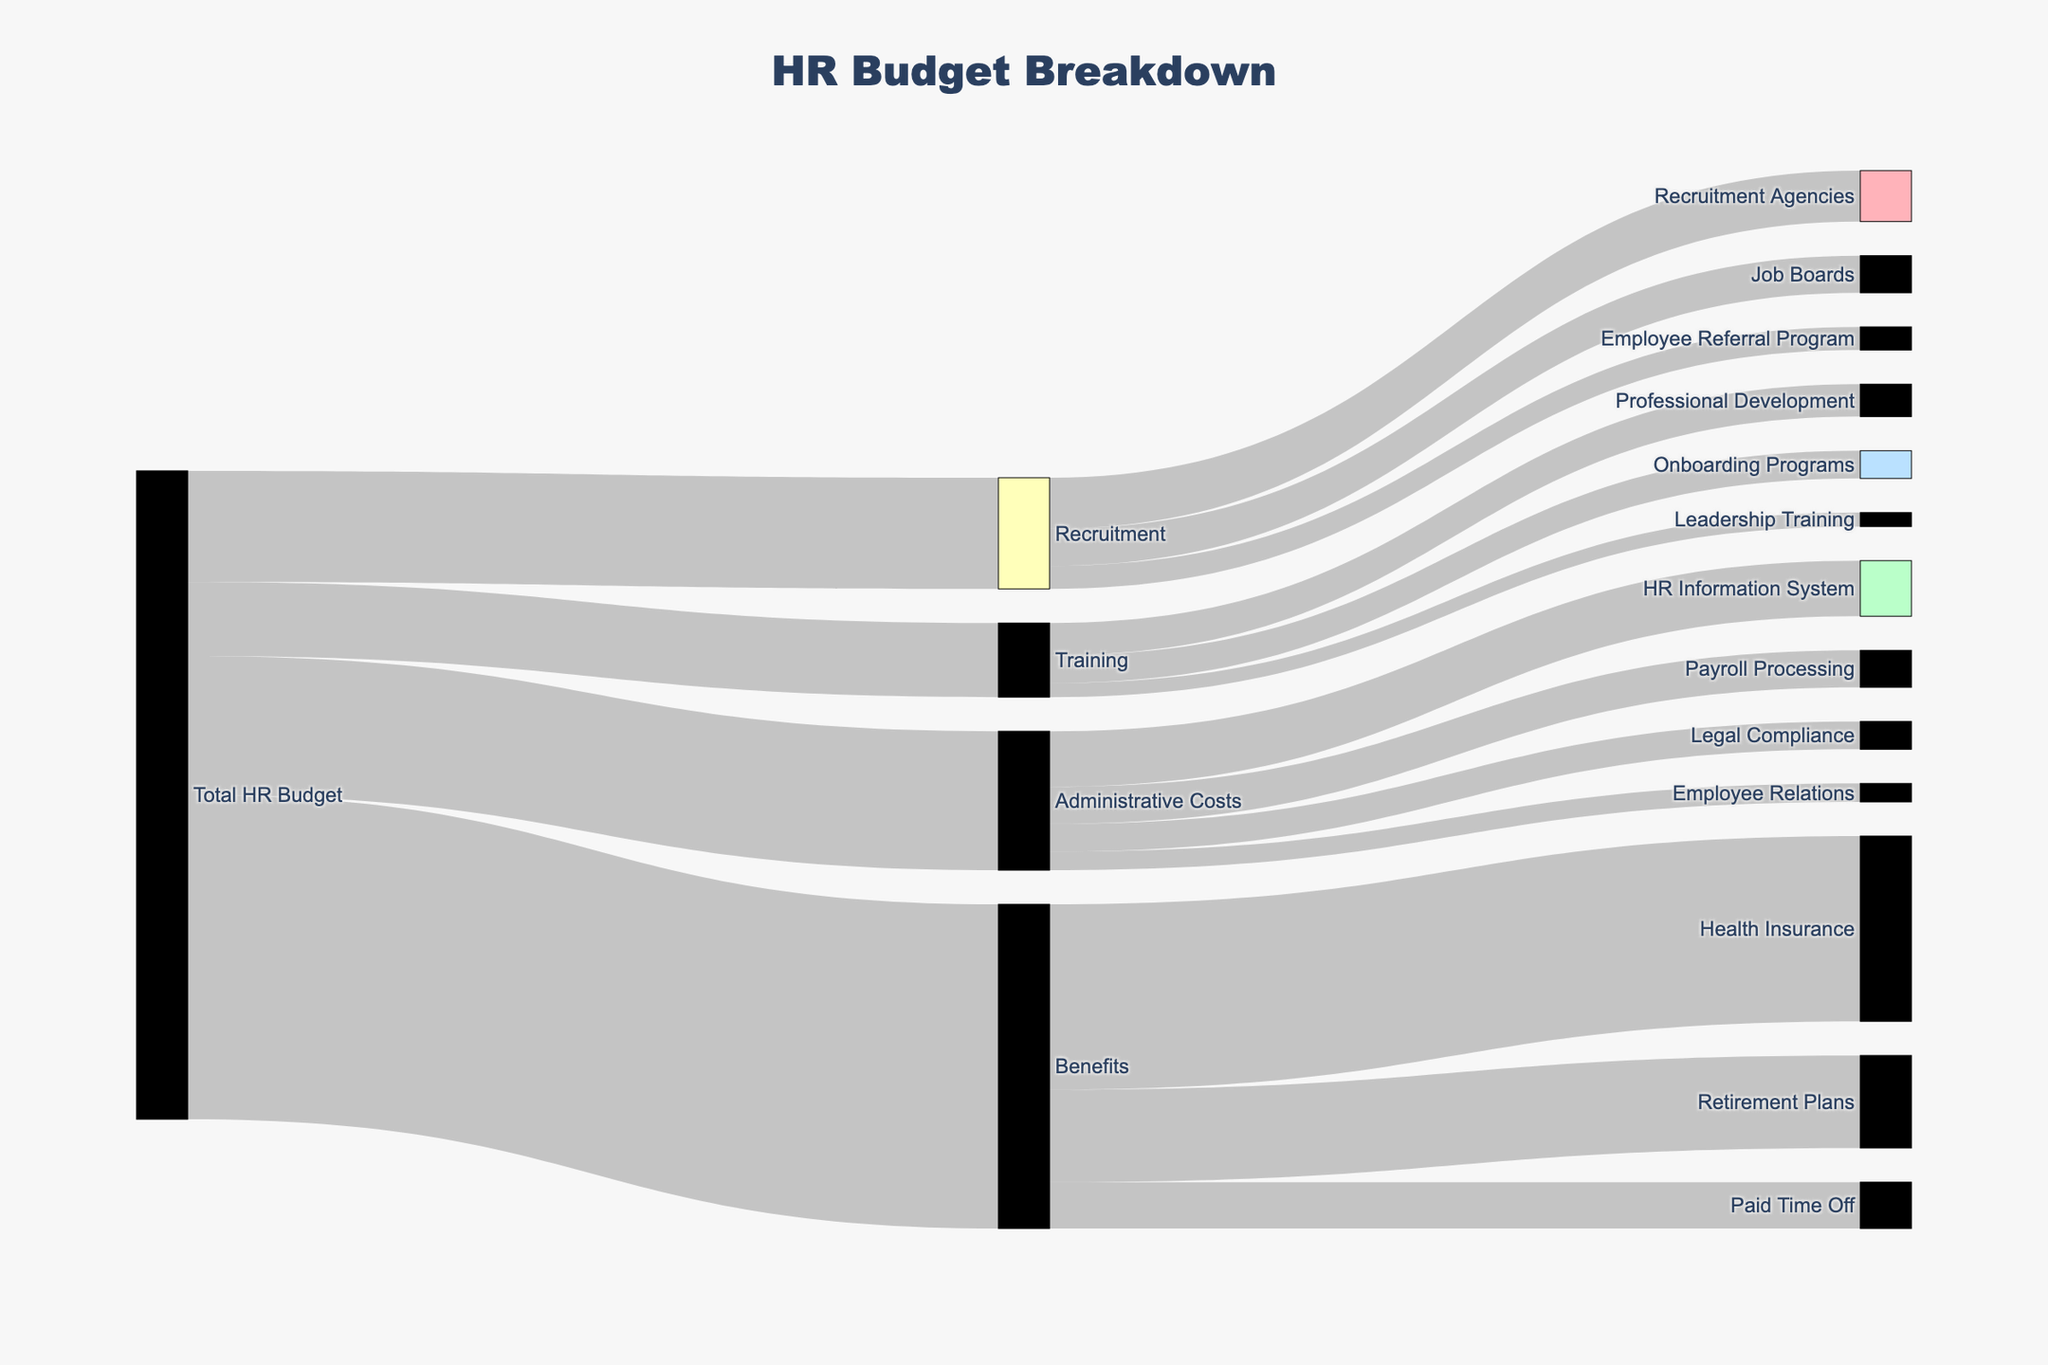How much of the total HR budget is allocated to Recruitment? The Sankey diagram shows the flow from the Total HR Budget to Recruitment. According to the figure, the amount directed to Recruitment is clearly labeled.
Answer: $120,000 How does the expenditure on Job Boards compare to Recruitment Agencies? To answer this, we need to find both values flowing from Recruitment. The diagram shows $40,000 for Job Boards and $55,000 for Recruitment Agencies. Job Boards cost $15,000 less than Recruitment Agencies.
Answer: Job Boards cost $15,000 less What is the total expenditure on Administrative Costs? Trace from Administrative Costs to its sub-categories and add the labeled values: $60,000 (HR Information System) + $40,000 (Payroll Processing) + $30,000 (Legal Compliance) + $20,000 (Employee Relations). The total sum is $150,000.
Answer: $150,000 Which sub-category under Benefits has the highest expense? Look at the flow from Benefits to its sub-categories. The highest value is $200,000 for Health Insurance, as shown in the diagram.
Answer: Health Insurance What percentage of the Recruitment budget is spent on Employee Referral Program? The Recruitment budget is $120,000. The expenditure on Employee Referral Program is $25,000. To find the percentage: (25,000 / 120,000) * 100 = 20.83%.
Answer: 20.83% What is the difference between the total budget for Training and Administrative Costs? The total budget for Training is $80,000 and for Administrative Costs, it is $150,000. The difference is $150,000 - $80,000 = $70,000.
Answer: $70,000 Which category, Training or Administrative Costs, has more sub-categories? Training has 3 sub-categories (Onboarding Programs, Professional Development, Leadership Training), while Administrative Costs has 4 sub-categories (HR Information System, Payroll Processing, Legal Compliance, Employee Relations).
Answer: Administrative Costs How much of the Benefits budget is allocated to Retirement Plans compared to Paid Time Off? Under Benefits, Retirement Plans are allocated $100,000 and Paid Time Off $50,000. Retirement Plans receive $50,000 more than Paid Time Off.
Answer: Retirement Plans receive $50,000 more What is the smallest allocation within Recruitment? Compare the three sub-categories under Recruitment: Job Boards ($40,000), Employee Referral Program ($25,000), Recruitment Agencies ($55,000). The smallest is Employee Referral Program at $25,000.
Answer: Employee Referral Program What is the total amount spent on Onboarding Programs and Leadership Training under Training? Under Training, Onboarding Programs are $30,000, and Leadership Training is $15,000. The total is $30,000 + $15,000 = $45,000.
Answer: $45,000 